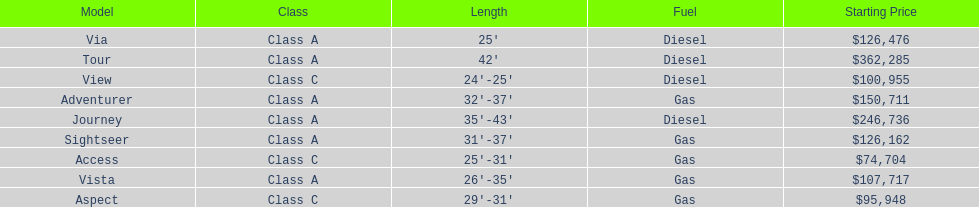Which model has the lowest started price? Access. 